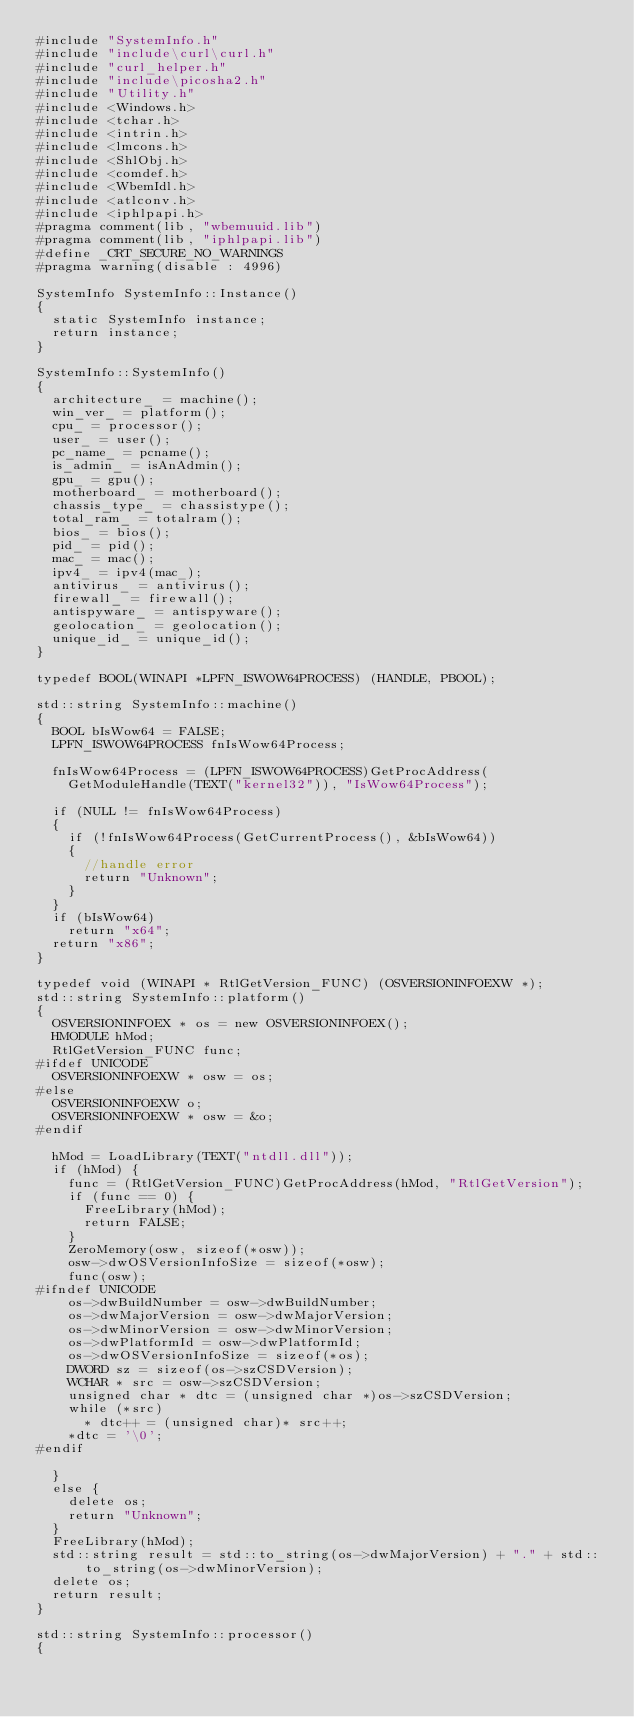<code> <loc_0><loc_0><loc_500><loc_500><_C++_>#include "SystemInfo.h"
#include "include\curl\curl.h"
#include "curl_helper.h"
#include "include\picosha2.h"
#include "Utility.h"
#include <Windows.h>
#include <tchar.h>
#include <intrin.h>
#include <lmcons.h>
#include <ShlObj.h>
#include <comdef.h>
#include <WbemIdl.h>
#include <atlconv.h>
#include <iphlpapi.h>
#pragma comment(lib, "wbemuuid.lib")
#pragma comment(lib, "iphlpapi.lib")
#define _CRT_SECURE_NO_WARNINGS
#pragma warning(disable : 4996)

SystemInfo SystemInfo::Instance()
{
	static SystemInfo instance;
	return instance;
}

SystemInfo::SystemInfo()
{
	architecture_ = machine();
	win_ver_ = platform();
	cpu_ = processor();
	user_ = user();
	pc_name_ = pcname();
	is_admin_ = isAnAdmin();
	gpu_ = gpu();
	motherboard_ = motherboard();
	chassis_type_ = chassistype();
	total_ram_ = totalram();
	bios_ = bios();
	pid_ = pid();
	mac_ = mac();
	ipv4_ = ipv4(mac_);
	antivirus_ = antivirus();
	firewall_ = firewall();
	antispyware_ = antispyware();
	geolocation_ = geolocation();
	unique_id_ = unique_id();
}

typedef BOOL(WINAPI *LPFN_ISWOW64PROCESS) (HANDLE, PBOOL);

std::string SystemInfo::machine()
{
	BOOL bIsWow64 = FALSE;
	LPFN_ISWOW64PROCESS fnIsWow64Process;

	fnIsWow64Process = (LPFN_ISWOW64PROCESS)GetProcAddress(
		GetModuleHandle(TEXT("kernel32")), "IsWow64Process");

	if (NULL != fnIsWow64Process)
	{
		if (!fnIsWow64Process(GetCurrentProcess(), &bIsWow64))
		{
			//handle error
			return "Unknown";
		}
	}
	if (bIsWow64)
		return "x64";
	return "x86";
}

typedef void (WINAPI * RtlGetVersion_FUNC) (OSVERSIONINFOEXW *);
std::string SystemInfo::platform()
{
	OSVERSIONINFOEX * os = new OSVERSIONINFOEX();
	HMODULE hMod;
	RtlGetVersion_FUNC func;
#ifdef UNICODE
	OSVERSIONINFOEXW * osw = os;
#else
	OSVERSIONINFOEXW o;
	OSVERSIONINFOEXW * osw = &o;
#endif

	hMod = LoadLibrary(TEXT("ntdll.dll"));
	if (hMod) {
		func = (RtlGetVersion_FUNC)GetProcAddress(hMod, "RtlGetVersion");
		if (func == 0) {
			FreeLibrary(hMod);
			return FALSE;
		}
		ZeroMemory(osw, sizeof(*osw));
		osw->dwOSVersionInfoSize = sizeof(*osw);
		func(osw);
#ifndef UNICODE
		os->dwBuildNumber = osw->dwBuildNumber;
		os->dwMajorVersion = osw->dwMajorVersion;
		os->dwMinorVersion = osw->dwMinorVersion;
		os->dwPlatformId = osw->dwPlatformId;
		os->dwOSVersionInfoSize = sizeof(*os);
		DWORD sz = sizeof(os->szCSDVersion);
		WCHAR * src = osw->szCSDVersion;
		unsigned char * dtc = (unsigned char *)os->szCSDVersion;
		while (*src)
			* dtc++ = (unsigned char)* src++;
		*dtc = '\0';
#endif

	}
	else {
		delete os;
		return "Unknown";
	}
	FreeLibrary(hMod);
	std::string result = std::to_string(os->dwMajorVersion) + "." + std::to_string(os->dwMinorVersion);
	delete os;
	return result;
}

std::string SystemInfo::processor()
{</code> 